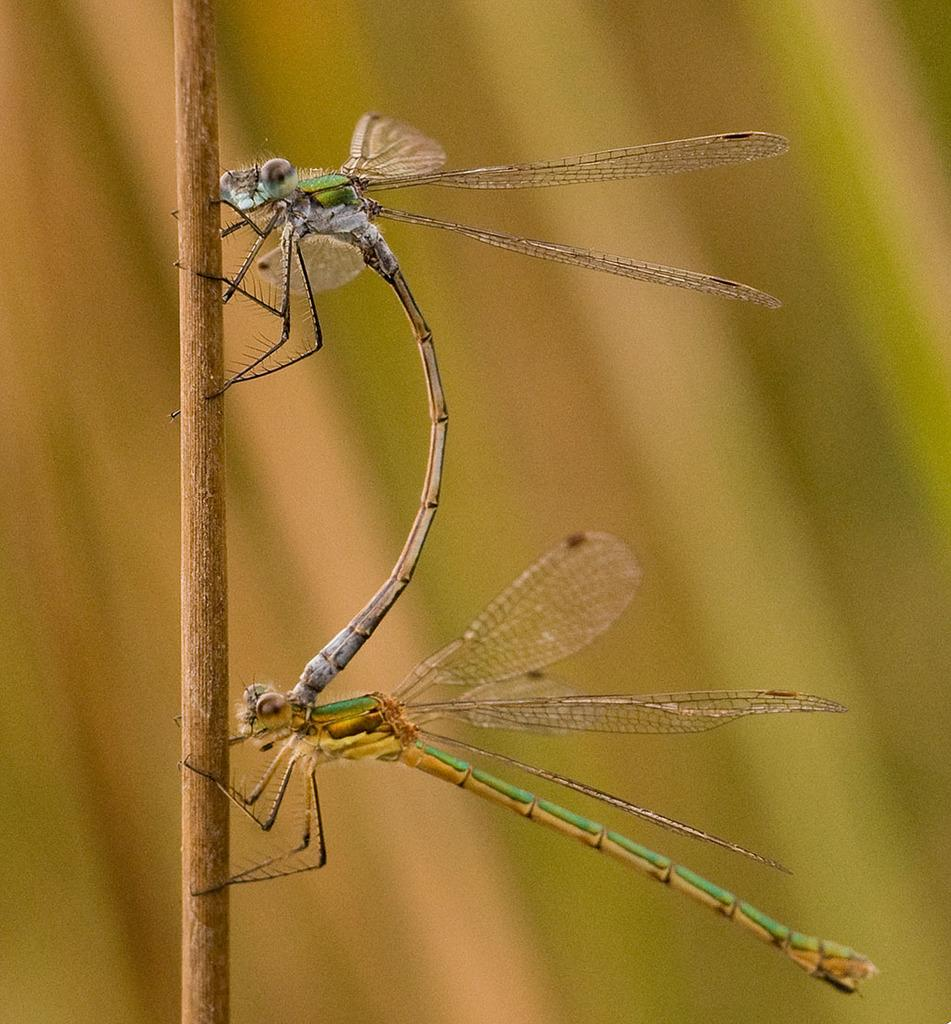What insects are present in the image? There are two damselflies in the image. What are the damselflies holding in the image? The damselflies are holding a bamboo stick. How many cattle can be seen grazing in the image? There are no cattle present in the image; it features two damselflies holding a bamboo stick. What type of fruit is being used as a prop by the damselflies in the image? There is no fruit present in the image; the damselflies are holding a bamboo stick. 